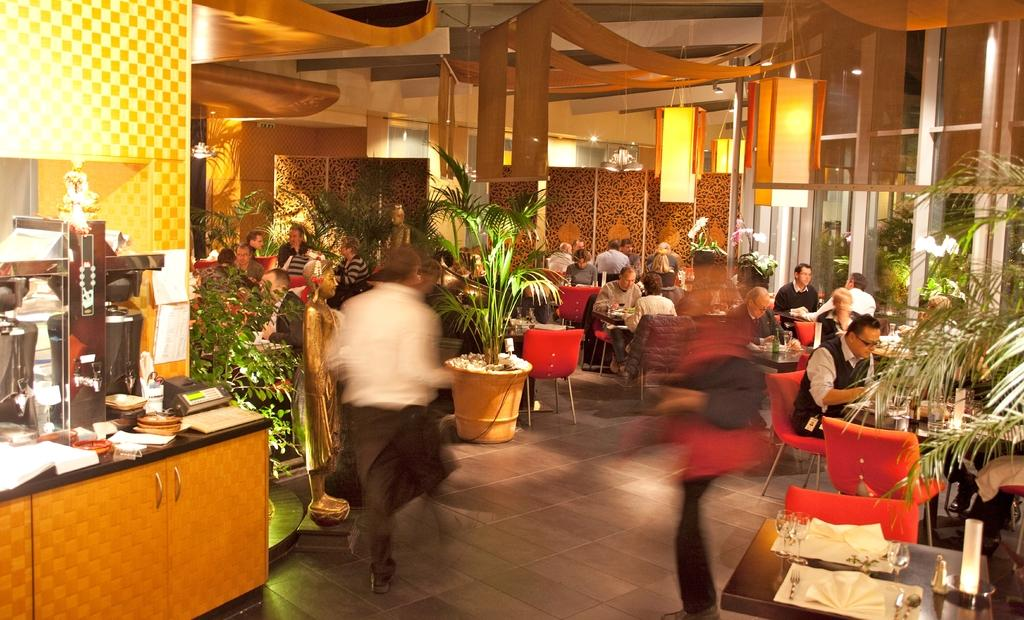How many people are in the image? There is a group of persons in the image. Where are the persons located? The persons are in a hotel. What are the persons doing in the image? Some of the persons are sitting, while others are standing. What street can be seen in the image? There is no street visible in the image; it takes place inside a hotel. 